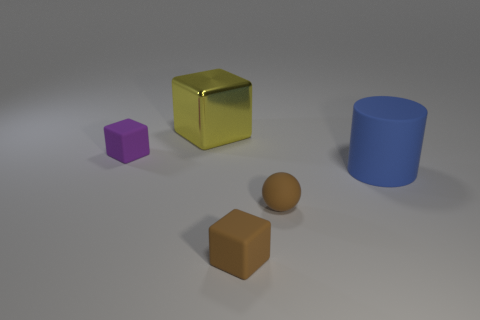Can you tell me which objects are closer to the gold cube? Certainly, the objects that are closer to the gold cube are the purple cube on its left and the brown cube at its front. The blue cylinder is further away towards the right. 